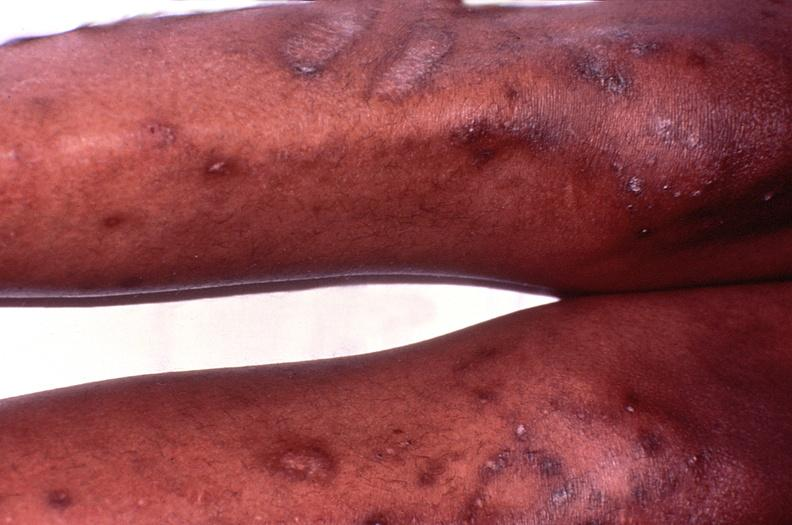where is this?
Answer the question using a single word or phrase. Skin 